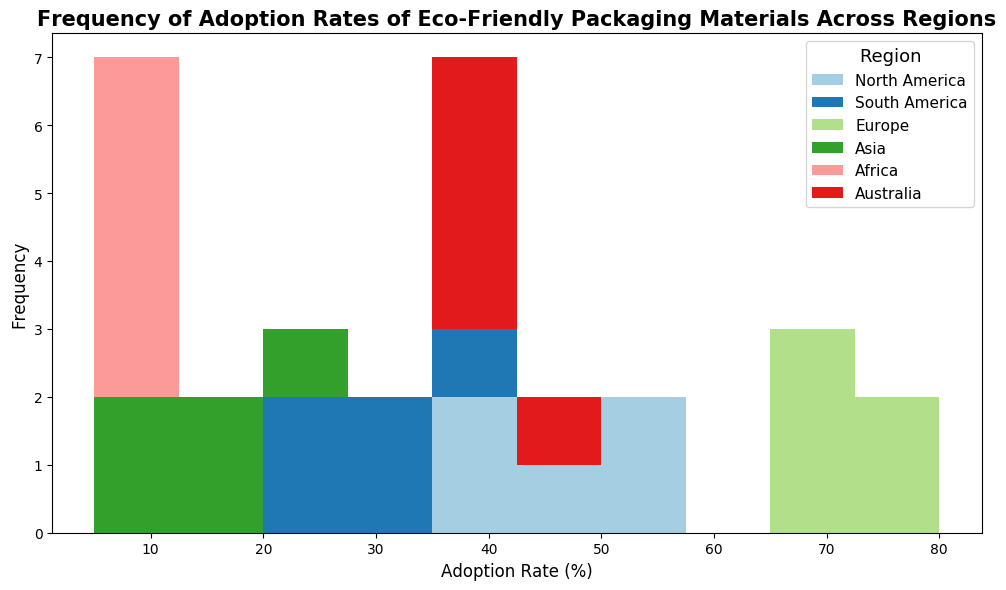What's the most frequently observed adoption rate range for North America? By examining the histogram, locate the bin representing North America with the highest frequency of data points. The height of the bar indicates the frequency of adoption rates within that range.
Answer: 40-45% Which region has the lowest overall adoption rates? Identify the region with the bars shifted furthest to the left in the histogram. Lower adoption rates are indicated by bars near the 0% side of the x-axis.
Answer: Africa How do the adoption rates in Asia compare to those in Europe? Compare the bars representing Asia and Europe. Asia's bars are clustered in lower adoption rate bins (10%-20%), while Europe's bars are in higher adoption rate bins (65%-80%). This shows Asia has lower adoption rates compared to Europe.
Answer: Lower in Asia What is the range of adoption rates in South America? South America's adoption rate bars span from the lowest to the highest observed values for this region. From the histogram, identify the lowest and highest values for South America.
Answer: 20%-35% Which region has the widest spread of adoption rates? Observe the width of the bars' spread in the histogram for each region. The region with bars covering the broadest range on the x-axis has the widest spread.
Answer: North America Are there more adoption rates in the 30%-40% range or the 60%-70% range? By looking at the heights of the bars in these ranges, count the number of regions represented and the height to compare frequencies.
Answer: 30%-40% range How many regions have adoption rates peaking above 50%? Identify regions where bars in the histogram extend beyond the 50% mark. Count the number of such regions.
Answer: 1 (Europe) Which region shows the highest variance in adoption rates? Examine the width of the bars spread for each region. Higher variance is indicated by a broader distribution along the x-axis.
Answer: North America If we focus on higher adoption rates, which region shows the strongest performance? Locate the region with the tallest bars in the upper range (higher adoption rates) of the histogram.
Answer: Europe Do any regions have overlapping adoption rate ranges, and which regions are they? Identify regions where bars exist in the same bins, specifically overlapping ranges to see if they share similar adoption rate figures.
Answer: North America and Australia 